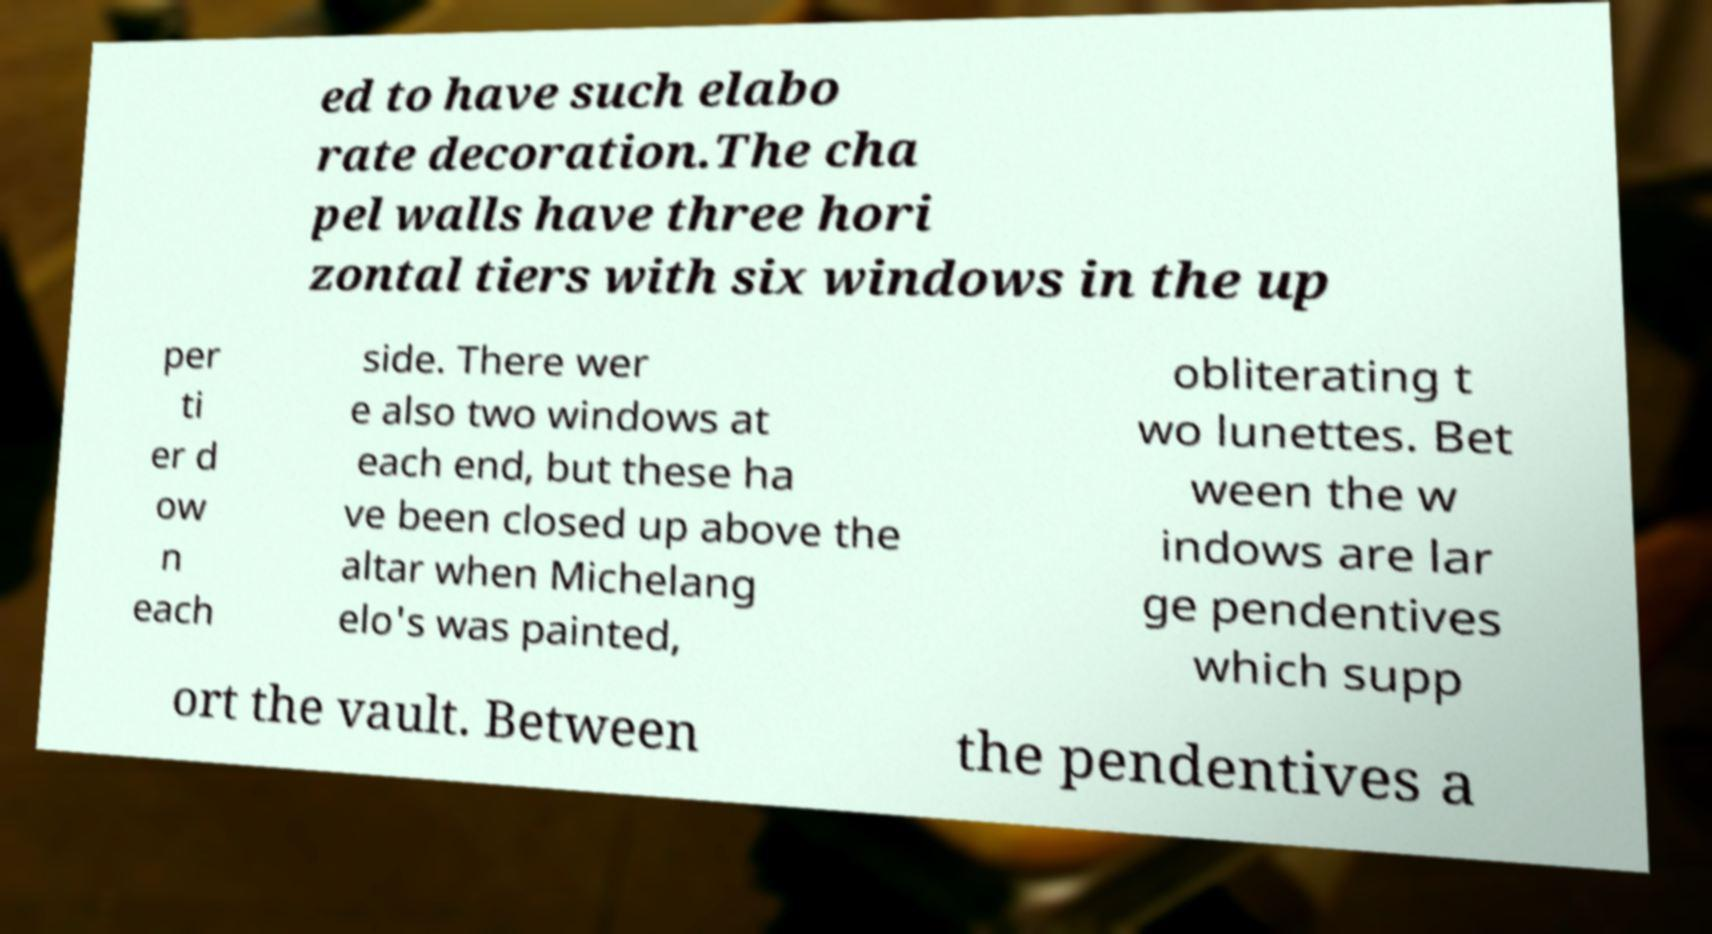For documentation purposes, I need the text within this image transcribed. Could you provide that? ed to have such elabo rate decoration.The cha pel walls have three hori zontal tiers with six windows in the up per ti er d ow n each side. There wer e also two windows at each end, but these ha ve been closed up above the altar when Michelang elo's was painted, obliterating t wo lunettes. Bet ween the w indows are lar ge pendentives which supp ort the vault. Between the pendentives a 